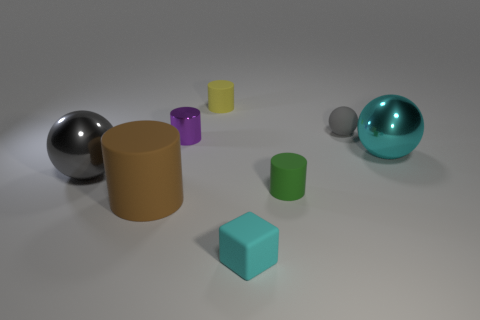Add 2 blue metal things. How many objects exist? 10 Subtract all spheres. How many objects are left? 5 Add 7 tiny rubber balls. How many tiny rubber balls exist? 8 Subtract 0 cyan cylinders. How many objects are left? 8 Subtract all large cyan balls. Subtract all large brown matte objects. How many objects are left? 6 Add 8 green matte cylinders. How many green matte cylinders are left? 9 